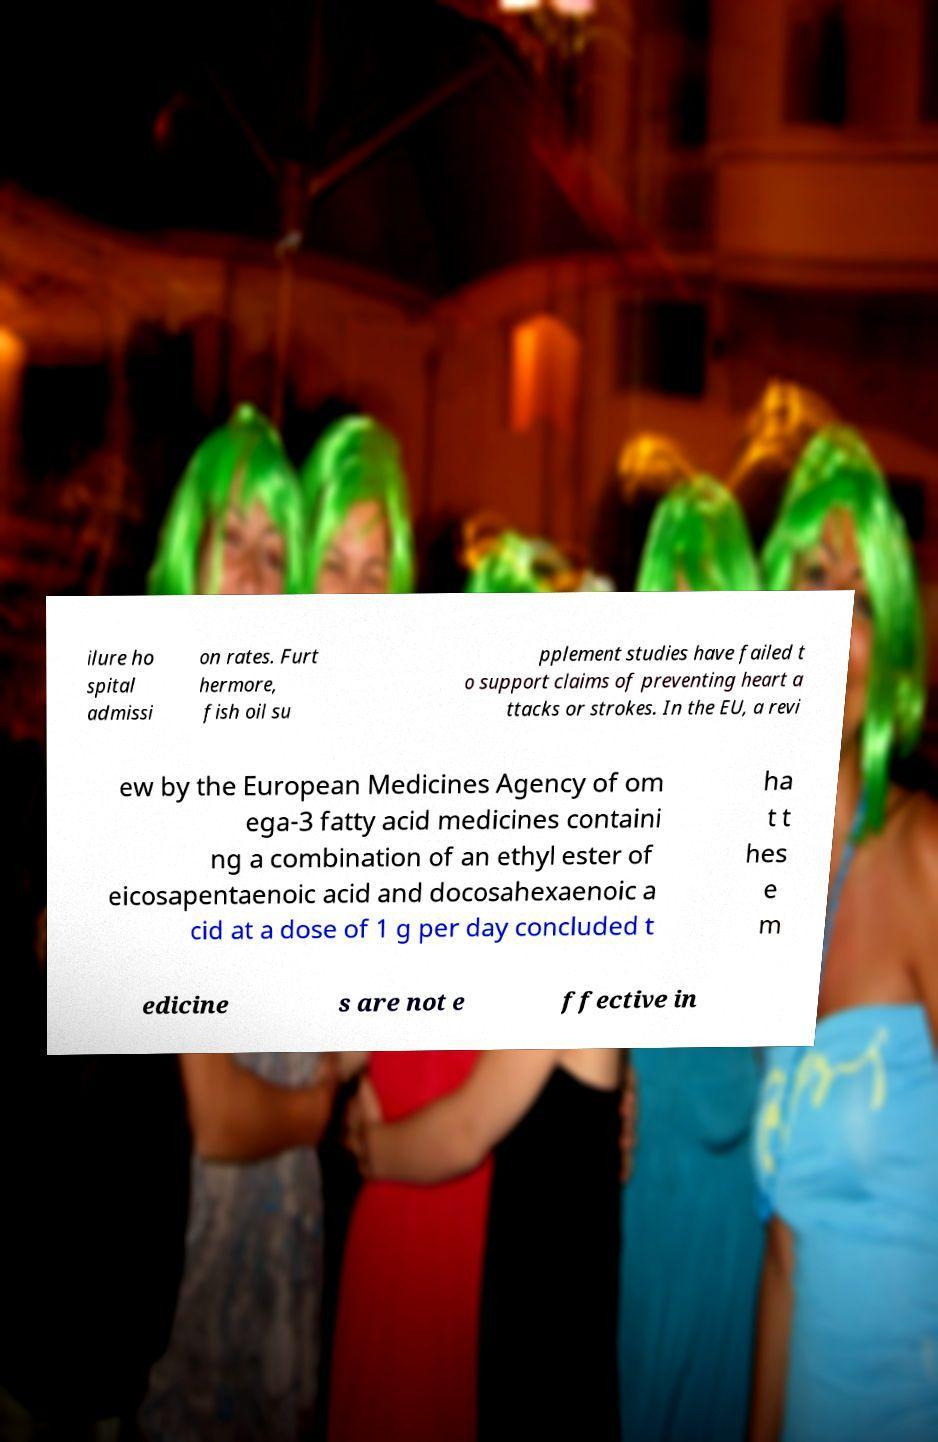There's text embedded in this image that I need extracted. Can you transcribe it verbatim? ilure ho spital admissi on rates. Furt hermore, fish oil su pplement studies have failed t o support claims of preventing heart a ttacks or strokes. In the EU, a revi ew by the European Medicines Agency of om ega-3 fatty acid medicines containi ng a combination of an ethyl ester of eicosapentaenoic acid and docosahexaenoic a cid at a dose of 1 g per day concluded t ha t t hes e m edicine s are not e ffective in 